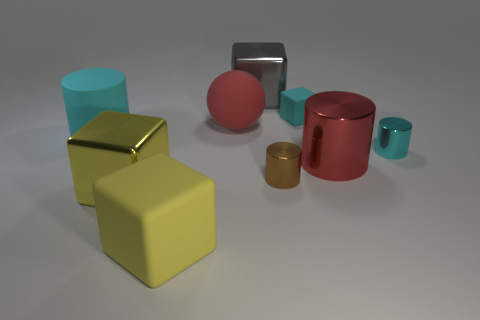Add 1 small objects. How many objects exist? 10 Subtract all brown cylinders. How many cylinders are left? 3 Subtract 3 cylinders. How many cylinders are left? 1 Subtract all cyan blocks. How many cyan cylinders are left? 2 Subtract all brown cylinders. How many cylinders are left? 3 Subtract all balls. How many objects are left? 8 Add 4 large brown spheres. How many large brown spheres exist? 4 Subtract 0 yellow balls. How many objects are left? 9 Subtract all gray balls. Subtract all brown cylinders. How many balls are left? 1 Subtract all small green rubber blocks. Subtract all red spheres. How many objects are left? 8 